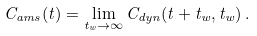<formula> <loc_0><loc_0><loc_500><loc_500>C _ { a m s } ( t ) = \lim _ { t _ { w } \to \infty } C _ { d y n } ( t + t _ { w } , t _ { w } ) \, .</formula> 